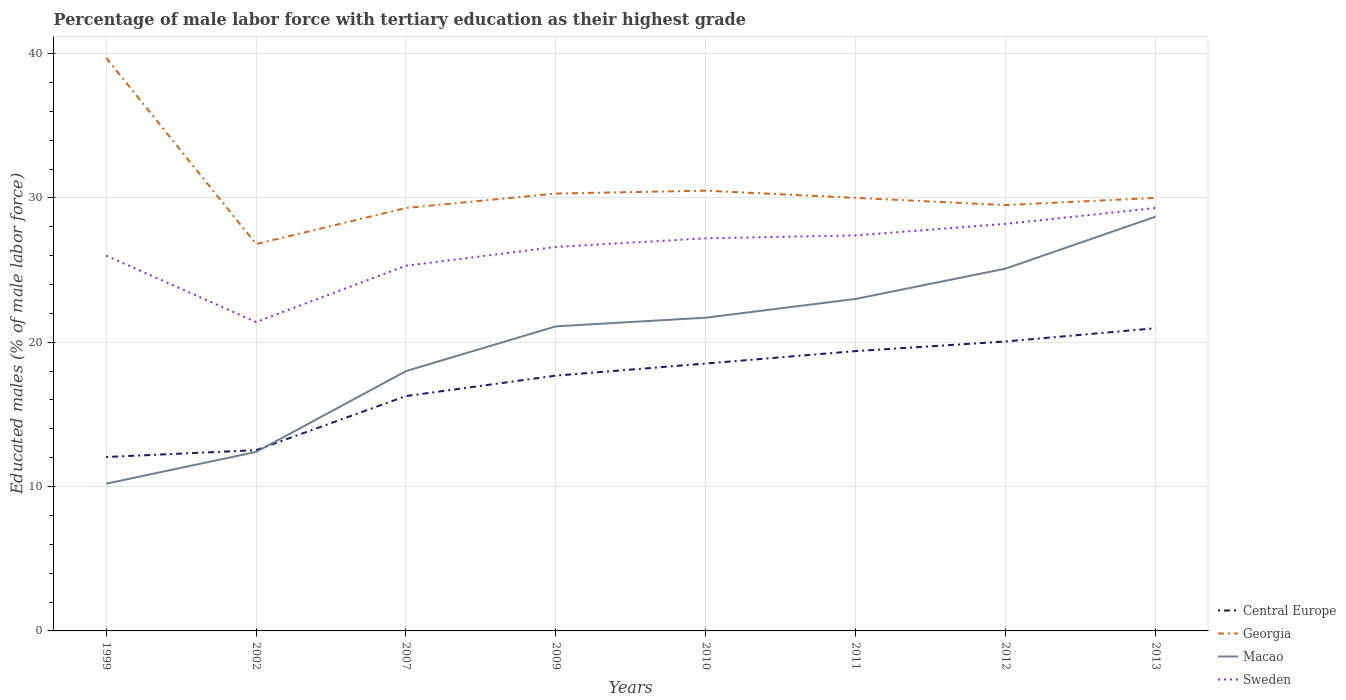Is the number of lines equal to the number of legend labels?
Keep it short and to the point. Yes. Across all years, what is the maximum percentage of male labor force with tertiary education in Macao?
Your answer should be very brief. 10.2. In which year was the percentage of male labor force with tertiary education in Macao maximum?
Give a very brief answer. 1999. What is the total percentage of male labor force with tertiary education in Central Europe in the graph?
Your answer should be compact. -0.47. What is the difference between the highest and the second highest percentage of male labor force with tertiary education in Sweden?
Make the answer very short. 7.9. What is the difference between the highest and the lowest percentage of male labor force with tertiary education in Macao?
Give a very brief answer. 5. How many lines are there?
Ensure brevity in your answer.  4. What is the difference between two consecutive major ticks on the Y-axis?
Provide a short and direct response. 10. Are the values on the major ticks of Y-axis written in scientific E-notation?
Your answer should be very brief. No. How are the legend labels stacked?
Your response must be concise. Vertical. What is the title of the graph?
Make the answer very short. Percentage of male labor force with tertiary education as their highest grade. Does "American Samoa" appear as one of the legend labels in the graph?
Provide a succinct answer. No. What is the label or title of the X-axis?
Make the answer very short. Years. What is the label or title of the Y-axis?
Your response must be concise. Educated males (% of male labor force). What is the Educated males (% of male labor force) in Central Europe in 1999?
Your answer should be very brief. 12.05. What is the Educated males (% of male labor force) of Georgia in 1999?
Ensure brevity in your answer.  39.7. What is the Educated males (% of male labor force) of Macao in 1999?
Make the answer very short. 10.2. What is the Educated males (% of male labor force) in Central Europe in 2002?
Provide a succinct answer. 12.52. What is the Educated males (% of male labor force) of Georgia in 2002?
Offer a very short reply. 26.8. What is the Educated males (% of male labor force) of Macao in 2002?
Provide a short and direct response. 12.4. What is the Educated males (% of male labor force) in Sweden in 2002?
Keep it short and to the point. 21.4. What is the Educated males (% of male labor force) of Central Europe in 2007?
Your answer should be very brief. 16.27. What is the Educated males (% of male labor force) of Georgia in 2007?
Keep it short and to the point. 29.3. What is the Educated males (% of male labor force) in Macao in 2007?
Your response must be concise. 18. What is the Educated males (% of male labor force) in Sweden in 2007?
Ensure brevity in your answer.  25.3. What is the Educated males (% of male labor force) in Central Europe in 2009?
Provide a succinct answer. 17.69. What is the Educated males (% of male labor force) of Georgia in 2009?
Provide a succinct answer. 30.3. What is the Educated males (% of male labor force) in Macao in 2009?
Offer a very short reply. 21.1. What is the Educated males (% of male labor force) in Sweden in 2009?
Keep it short and to the point. 26.6. What is the Educated males (% of male labor force) of Central Europe in 2010?
Offer a terse response. 18.52. What is the Educated males (% of male labor force) in Georgia in 2010?
Offer a terse response. 30.5. What is the Educated males (% of male labor force) in Macao in 2010?
Offer a very short reply. 21.7. What is the Educated males (% of male labor force) in Sweden in 2010?
Ensure brevity in your answer.  27.2. What is the Educated males (% of male labor force) of Central Europe in 2011?
Offer a very short reply. 19.39. What is the Educated males (% of male labor force) of Macao in 2011?
Your response must be concise. 23. What is the Educated males (% of male labor force) in Sweden in 2011?
Your answer should be compact. 27.4. What is the Educated males (% of male labor force) of Central Europe in 2012?
Offer a very short reply. 20.05. What is the Educated males (% of male labor force) of Georgia in 2012?
Offer a very short reply. 29.5. What is the Educated males (% of male labor force) in Macao in 2012?
Ensure brevity in your answer.  25.1. What is the Educated males (% of male labor force) of Sweden in 2012?
Ensure brevity in your answer.  28.2. What is the Educated males (% of male labor force) of Central Europe in 2013?
Keep it short and to the point. 20.97. What is the Educated males (% of male labor force) in Georgia in 2013?
Ensure brevity in your answer.  30. What is the Educated males (% of male labor force) of Macao in 2013?
Offer a very short reply. 28.7. What is the Educated males (% of male labor force) of Sweden in 2013?
Give a very brief answer. 29.3. Across all years, what is the maximum Educated males (% of male labor force) in Central Europe?
Keep it short and to the point. 20.97. Across all years, what is the maximum Educated males (% of male labor force) in Georgia?
Make the answer very short. 39.7. Across all years, what is the maximum Educated males (% of male labor force) of Macao?
Keep it short and to the point. 28.7. Across all years, what is the maximum Educated males (% of male labor force) in Sweden?
Offer a very short reply. 29.3. Across all years, what is the minimum Educated males (% of male labor force) of Central Europe?
Provide a short and direct response. 12.05. Across all years, what is the minimum Educated males (% of male labor force) in Georgia?
Provide a succinct answer. 26.8. Across all years, what is the minimum Educated males (% of male labor force) of Macao?
Give a very brief answer. 10.2. Across all years, what is the minimum Educated males (% of male labor force) in Sweden?
Your answer should be very brief. 21.4. What is the total Educated males (% of male labor force) of Central Europe in the graph?
Offer a terse response. 137.46. What is the total Educated males (% of male labor force) of Georgia in the graph?
Provide a short and direct response. 246.1. What is the total Educated males (% of male labor force) of Macao in the graph?
Your answer should be very brief. 160.2. What is the total Educated males (% of male labor force) in Sweden in the graph?
Make the answer very short. 211.4. What is the difference between the Educated males (% of male labor force) in Central Europe in 1999 and that in 2002?
Provide a short and direct response. -0.47. What is the difference between the Educated males (% of male labor force) of Georgia in 1999 and that in 2002?
Keep it short and to the point. 12.9. What is the difference between the Educated males (% of male labor force) of Sweden in 1999 and that in 2002?
Offer a terse response. 4.6. What is the difference between the Educated males (% of male labor force) of Central Europe in 1999 and that in 2007?
Your answer should be very brief. -4.22. What is the difference between the Educated males (% of male labor force) in Georgia in 1999 and that in 2007?
Your answer should be very brief. 10.4. What is the difference between the Educated males (% of male labor force) in Macao in 1999 and that in 2007?
Offer a very short reply. -7.8. What is the difference between the Educated males (% of male labor force) of Sweden in 1999 and that in 2007?
Your response must be concise. 0.7. What is the difference between the Educated males (% of male labor force) of Central Europe in 1999 and that in 2009?
Make the answer very short. -5.64. What is the difference between the Educated males (% of male labor force) of Macao in 1999 and that in 2009?
Provide a succinct answer. -10.9. What is the difference between the Educated males (% of male labor force) in Sweden in 1999 and that in 2009?
Provide a short and direct response. -0.6. What is the difference between the Educated males (% of male labor force) of Central Europe in 1999 and that in 2010?
Offer a terse response. -6.47. What is the difference between the Educated males (% of male labor force) in Georgia in 1999 and that in 2010?
Make the answer very short. 9.2. What is the difference between the Educated males (% of male labor force) of Macao in 1999 and that in 2010?
Ensure brevity in your answer.  -11.5. What is the difference between the Educated males (% of male labor force) in Sweden in 1999 and that in 2010?
Keep it short and to the point. -1.2. What is the difference between the Educated males (% of male labor force) in Central Europe in 1999 and that in 2011?
Make the answer very short. -7.34. What is the difference between the Educated males (% of male labor force) in Macao in 1999 and that in 2011?
Your response must be concise. -12.8. What is the difference between the Educated males (% of male labor force) in Sweden in 1999 and that in 2011?
Your answer should be compact. -1.4. What is the difference between the Educated males (% of male labor force) of Central Europe in 1999 and that in 2012?
Provide a short and direct response. -8. What is the difference between the Educated males (% of male labor force) in Macao in 1999 and that in 2012?
Your response must be concise. -14.9. What is the difference between the Educated males (% of male labor force) of Central Europe in 1999 and that in 2013?
Provide a succinct answer. -8.92. What is the difference between the Educated males (% of male labor force) of Georgia in 1999 and that in 2013?
Offer a very short reply. 9.7. What is the difference between the Educated males (% of male labor force) in Macao in 1999 and that in 2013?
Provide a short and direct response. -18.5. What is the difference between the Educated males (% of male labor force) of Sweden in 1999 and that in 2013?
Offer a very short reply. -3.3. What is the difference between the Educated males (% of male labor force) of Central Europe in 2002 and that in 2007?
Offer a very short reply. -3.75. What is the difference between the Educated males (% of male labor force) of Macao in 2002 and that in 2007?
Your answer should be compact. -5.6. What is the difference between the Educated males (% of male labor force) in Central Europe in 2002 and that in 2009?
Offer a terse response. -5.16. What is the difference between the Educated males (% of male labor force) in Macao in 2002 and that in 2009?
Your response must be concise. -8.7. What is the difference between the Educated males (% of male labor force) in Sweden in 2002 and that in 2009?
Provide a succinct answer. -5.2. What is the difference between the Educated males (% of male labor force) in Central Europe in 2002 and that in 2010?
Your answer should be very brief. -6. What is the difference between the Educated males (% of male labor force) of Macao in 2002 and that in 2010?
Give a very brief answer. -9.3. What is the difference between the Educated males (% of male labor force) of Sweden in 2002 and that in 2010?
Ensure brevity in your answer.  -5.8. What is the difference between the Educated males (% of male labor force) in Central Europe in 2002 and that in 2011?
Provide a succinct answer. -6.86. What is the difference between the Educated males (% of male labor force) in Macao in 2002 and that in 2011?
Your answer should be compact. -10.6. What is the difference between the Educated males (% of male labor force) in Central Europe in 2002 and that in 2012?
Ensure brevity in your answer.  -7.53. What is the difference between the Educated males (% of male labor force) in Macao in 2002 and that in 2012?
Your response must be concise. -12.7. What is the difference between the Educated males (% of male labor force) of Sweden in 2002 and that in 2012?
Provide a short and direct response. -6.8. What is the difference between the Educated males (% of male labor force) of Central Europe in 2002 and that in 2013?
Offer a very short reply. -8.45. What is the difference between the Educated males (% of male labor force) of Georgia in 2002 and that in 2013?
Offer a very short reply. -3.2. What is the difference between the Educated males (% of male labor force) of Macao in 2002 and that in 2013?
Your answer should be compact. -16.3. What is the difference between the Educated males (% of male labor force) in Sweden in 2002 and that in 2013?
Your answer should be compact. -7.9. What is the difference between the Educated males (% of male labor force) in Central Europe in 2007 and that in 2009?
Your answer should be compact. -1.42. What is the difference between the Educated males (% of male labor force) in Sweden in 2007 and that in 2009?
Your answer should be compact. -1.3. What is the difference between the Educated males (% of male labor force) in Central Europe in 2007 and that in 2010?
Provide a short and direct response. -2.25. What is the difference between the Educated males (% of male labor force) in Macao in 2007 and that in 2010?
Provide a short and direct response. -3.7. What is the difference between the Educated males (% of male labor force) of Sweden in 2007 and that in 2010?
Ensure brevity in your answer.  -1.9. What is the difference between the Educated males (% of male labor force) in Central Europe in 2007 and that in 2011?
Offer a terse response. -3.12. What is the difference between the Educated males (% of male labor force) in Georgia in 2007 and that in 2011?
Your response must be concise. -0.7. What is the difference between the Educated males (% of male labor force) of Central Europe in 2007 and that in 2012?
Keep it short and to the point. -3.78. What is the difference between the Educated males (% of male labor force) in Central Europe in 2007 and that in 2013?
Your response must be concise. -4.7. What is the difference between the Educated males (% of male labor force) in Georgia in 2007 and that in 2013?
Your answer should be compact. -0.7. What is the difference between the Educated males (% of male labor force) of Macao in 2007 and that in 2013?
Your response must be concise. -10.7. What is the difference between the Educated males (% of male labor force) of Sweden in 2007 and that in 2013?
Provide a short and direct response. -4. What is the difference between the Educated males (% of male labor force) of Central Europe in 2009 and that in 2010?
Provide a short and direct response. -0.84. What is the difference between the Educated males (% of male labor force) of Georgia in 2009 and that in 2010?
Make the answer very short. -0.2. What is the difference between the Educated males (% of male labor force) of Sweden in 2009 and that in 2010?
Offer a very short reply. -0.6. What is the difference between the Educated males (% of male labor force) of Central Europe in 2009 and that in 2011?
Keep it short and to the point. -1.7. What is the difference between the Educated males (% of male labor force) of Georgia in 2009 and that in 2011?
Make the answer very short. 0.3. What is the difference between the Educated males (% of male labor force) of Central Europe in 2009 and that in 2012?
Keep it short and to the point. -2.37. What is the difference between the Educated males (% of male labor force) in Georgia in 2009 and that in 2012?
Provide a succinct answer. 0.8. What is the difference between the Educated males (% of male labor force) of Macao in 2009 and that in 2012?
Your answer should be very brief. -4. What is the difference between the Educated males (% of male labor force) in Sweden in 2009 and that in 2012?
Your answer should be very brief. -1.6. What is the difference between the Educated males (% of male labor force) in Central Europe in 2009 and that in 2013?
Your answer should be compact. -3.28. What is the difference between the Educated males (% of male labor force) of Central Europe in 2010 and that in 2011?
Ensure brevity in your answer.  -0.86. What is the difference between the Educated males (% of male labor force) of Sweden in 2010 and that in 2011?
Your answer should be very brief. -0.2. What is the difference between the Educated males (% of male labor force) in Central Europe in 2010 and that in 2012?
Give a very brief answer. -1.53. What is the difference between the Educated males (% of male labor force) of Sweden in 2010 and that in 2012?
Your response must be concise. -1. What is the difference between the Educated males (% of male labor force) of Central Europe in 2010 and that in 2013?
Your answer should be compact. -2.45. What is the difference between the Educated males (% of male labor force) in Georgia in 2010 and that in 2013?
Offer a very short reply. 0.5. What is the difference between the Educated males (% of male labor force) of Macao in 2010 and that in 2013?
Ensure brevity in your answer.  -7. What is the difference between the Educated males (% of male labor force) of Sweden in 2010 and that in 2013?
Offer a very short reply. -2.1. What is the difference between the Educated males (% of male labor force) of Central Europe in 2011 and that in 2012?
Offer a very short reply. -0.66. What is the difference between the Educated males (% of male labor force) in Georgia in 2011 and that in 2012?
Give a very brief answer. 0.5. What is the difference between the Educated males (% of male labor force) of Central Europe in 2011 and that in 2013?
Offer a very short reply. -1.58. What is the difference between the Educated males (% of male labor force) of Macao in 2011 and that in 2013?
Your answer should be compact. -5.7. What is the difference between the Educated males (% of male labor force) of Central Europe in 2012 and that in 2013?
Keep it short and to the point. -0.92. What is the difference between the Educated males (% of male labor force) in Macao in 2012 and that in 2013?
Provide a succinct answer. -3.6. What is the difference between the Educated males (% of male labor force) in Central Europe in 1999 and the Educated males (% of male labor force) in Georgia in 2002?
Your response must be concise. -14.75. What is the difference between the Educated males (% of male labor force) of Central Europe in 1999 and the Educated males (% of male labor force) of Macao in 2002?
Give a very brief answer. -0.35. What is the difference between the Educated males (% of male labor force) of Central Europe in 1999 and the Educated males (% of male labor force) of Sweden in 2002?
Ensure brevity in your answer.  -9.35. What is the difference between the Educated males (% of male labor force) in Georgia in 1999 and the Educated males (% of male labor force) in Macao in 2002?
Your response must be concise. 27.3. What is the difference between the Educated males (% of male labor force) in Macao in 1999 and the Educated males (% of male labor force) in Sweden in 2002?
Keep it short and to the point. -11.2. What is the difference between the Educated males (% of male labor force) of Central Europe in 1999 and the Educated males (% of male labor force) of Georgia in 2007?
Give a very brief answer. -17.25. What is the difference between the Educated males (% of male labor force) in Central Europe in 1999 and the Educated males (% of male labor force) in Macao in 2007?
Provide a short and direct response. -5.95. What is the difference between the Educated males (% of male labor force) in Central Europe in 1999 and the Educated males (% of male labor force) in Sweden in 2007?
Your response must be concise. -13.25. What is the difference between the Educated males (% of male labor force) of Georgia in 1999 and the Educated males (% of male labor force) of Macao in 2007?
Your answer should be very brief. 21.7. What is the difference between the Educated males (% of male labor force) of Georgia in 1999 and the Educated males (% of male labor force) of Sweden in 2007?
Your answer should be very brief. 14.4. What is the difference between the Educated males (% of male labor force) in Macao in 1999 and the Educated males (% of male labor force) in Sweden in 2007?
Your answer should be very brief. -15.1. What is the difference between the Educated males (% of male labor force) in Central Europe in 1999 and the Educated males (% of male labor force) in Georgia in 2009?
Your response must be concise. -18.25. What is the difference between the Educated males (% of male labor force) of Central Europe in 1999 and the Educated males (% of male labor force) of Macao in 2009?
Give a very brief answer. -9.05. What is the difference between the Educated males (% of male labor force) in Central Europe in 1999 and the Educated males (% of male labor force) in Sweden in 2009?
Keep it short and to the point. -14.55. What is the difference between the Educated males (% of male labor force) of Georgia in 1999 and the Educated males (% of male labor force) of Macao in 2009?
Ensure brevity in your answer.  18.6. What is the difference between the Educated males (% of male labor force) in Macao in 1999 and the Educated males (% of male labor force) in Sweden in 2009?
Offer a terse response. -16.4. What is the difference between the Educated males (% of male labor force) in Central Europe in 1999 and the Educated males (% of male labor force) in Georgia in 2010?
Ensure brevity in your answer.  -18.45. What is the difference between the Educated males (% of male labor force) in Central Europe in 1999 and the Educated males (% of male labor force) in Macao in 2010?
Provide a short and direct response. -9.65. What is the difference between the Educated males (% of male labor force) of Central Europe in 1999 and the Educated males (% of male labor force) of Sweden in 2010?
Keep it short and to the point. -15.15. What is the difference between the Educated males (% of male labor force) in Georgia in 1999 and the Educated males (% of male labor force) in Macao in 2010?
Keep it short and to the point. 18. What is the difference between the Educated males (% of male labor force) of Macao in 1999 and the Educated males (% of male labor force) of Sweden in 2010?
Your answer should be compact. -17. What is the difference between the Educated males (% of male labor force) of Central Europe in 1999 and the Educated males (% of male labor force) of Georgia in 2011?
Keep it short and to the point. -17.95. What is the difference between the Educated males (% of male labor force) in Central Europe in 1999 and the Educated males (% of male labor force) in Macao in 2011?
Your answer should be very brief. -10.95. What is the difference between the Educated males (% of male labor force) of Central Europe in 1999 and the Educated males (% of male labor force) of Sweden in 2011?
Offer a terse response. -15.35. What is the difference between the Educated males (% of male labor force) of Georgia in 1999 and the Educated males (% of male labor force) of Sweden in 2011?
Provide a succinct answer. 12.3. What is the difference between the Educated males (% of male labor force) of Macao in 1999 and the Educated males (% of male labor force) of Sweden in 2011?
Offer a terse response. -17.2. What is the difference between the Educated males (% of male labor force) in Central Europe in 1999 and the Educated males (% of male labor force) in Georgia in 2012?
Your answer should be compact. -17.45. What is the difference between the Educated males (% of male labor force) of Central Europe in 1999 and the Educated males (% of male labor force) of Macao in 2012?
Provide a short and direct response. -13.05. What is the difference between the Educated males (% of male labor force) in Central Europe in 1999 and the Educated males (% of male labor force) in Sweden in 2012?
Keep it short and to the point. -16.15. What is the difference between the Educated males (% of male labor force) in Georgia in 1999 and the Educated males (% of male labor force) in Macao in 2012?
Provide a succinct answer. 14.6. What is the difference between the Educated males (% of male labor force) in Central Europe in 1999 and the Educated males (% of male labor force) in Georgia in 2013?
Make the answer very short. -17.95. What is the difference between the Educated males (% of male labor force) of Central Europe in 1999 and the Educated males (% of male labor force) of Macao in 2013?
Keep it short and to the point. -16.65. What is the difference between the Educated males (% of male labor force) in Central Europe in 1999 and the Educated males (% of male labor force) in Sweden in 2013?
Ensure brevity in your answer.  -17.25. What is the difference between the Educated males (% of male labor force) in Georgia in 1999 and the Educated males (% of male labor force) in Sweden in 2013?
Make the answer very short. 10.4. What is the difference between the Educated males (% of male labor force) of Macao in 1999 and the Educated males (% of male labor force) of Sweden in 2013?
Your response must be concise. -19.1. What is the difference between the Educated males (% of male labor force) of Central Europe in 2002 and the Educated males (% of male labor force) of Georgia in 2007?
Provide a short and direct response. -16.78. What is the difference between the Educated males (% of male labor force) of Central Europe in 2002 and the Educated males (% of male labor force) of Macao in 2007?
Make the answer very short. -5.48. What is the difference between the Educated males (% of male labor force) of Central Europe in 2002 and the Educated males (% of male labor force) of Sweden in 2007?
Make the answer very short. -12.78. What is the difference between the Educated males (% of male labor force) in Georgia in 2002 and the Educated males (% of male labor force) in Macao in 2007?
Make the answer very short. 8.8. What is the difference between the Educated males (% of male labor force) of Georgia in 2002 and the Educated males (% of male labor force) of Sweden in 2007?
Keep it short and to the point. 1.5. What is the difference between the Educated males (% of male labor force) of Macao in 2002 and the Educated males (% of male labor force) of Sweden in 2007?
Make the answer very short. -12.9. What is the difference between the Educated males (% of male labor force) in Central Europe in 2002 and the Educated males (% of male labor force) in Georgia in 2009?
Provide a short and direct response. -17.78. What is the difference between the Educated males (% of male labor force) of Central Europe in 2002 and the Educated males (% of male labor force) of Macao in 2009?
Your answer should be very brief. -8.58. What is the difference between the Educated males (% of male labor force) in Central Europe in 2002 and the Educated males (% of male labor force) in Sweden in 2009?
Offer a terse response. -14.08. What is the difference between the Educated males (% of male labor force) in Georgia in 2002 and the Educated males (% of male labor force) in Sweden in 2009?
Ensure brevity in your answer.  0.2. What is the difference between the Educated males (% of male labor force) in Macao in 2002 and the Educated males (% of male labor force) in Sweden in 2009?
Your response must be concise. -14.2. What is the difference between the Educated males (% of male labor force) of Central Europe in 2002 and the Educated males (% of male labor force) of Georgia in 2010?
Offer a very short reply. -17.98. What is the difference between the Educated males (% of male labor force) in Central Europe in 2002 and the Educated males (% of male labor force) in Macao in 2010?
Your answer should be compact. -9.18. What is the difference between the Educated males (% of male labor force) in Central Europe in 2002 and the Educated males (% of male labor force) in Sweden in 2010?
Your response must be concise. -14.68. What is the difference between the Educated males (% of male labor force) of Georgia in 2002 and the Educated males (% of male labor force) of Macao in 2010?
Make the answer very short. 5.1. What is the difference between the Educated males (% of male labor force) in Macao in 2002 and the Educated males (% of male labor force) in Sweden in 2010?
Offer a very short reply. -14.8. What is the difference between the Educated males (% of male labor force) of Central Europe in 2002 and the Educated males (% of male labor force) of Georgia in 2011?
Your response must be concise. -17.48. What is the difference between the Educated males (% of male labor force) of Central Europe in 2002 and the Educated males (% of male labor force) of Macao in 2011?
Your answer should be very brief. -10.48. What is the difference between the Educated males (% of male labor force) of Central Europe in 2002 and the Educated males (% of male labor force) of Sweden in 2011?
Make the answer very short. -14.88. What is the difference between the Educated males (% of male labor force) in Georgia in 2002 and the Educated males (% of male labor force) in Macao in 2011?
Offer a very short reply. 3.8. What is the difference between the Educated males (% of male labor force) of Georgia in 2002 and the Educated males (% of male labor force) of Sweden in 2011?
Give a very brief answer. -0.6. What is the difference between the Educated males (% of male labor force) in Macao in 2002 and the Educated males (% of male labor force) in Sweden in 2011?
Offer a very short reply. -15. What is the difference between the Educated males (% of male labor force) in Central Europe in 2002 and the Educated males (% of male labor force) in Georgia in 2012?
Offer a very short reply. -16.98. What is the difference between the Educated males (% of male labor force) of Central Europe in 2002 and the Educated males (% of male labor force) of Macao in 2012?
Keep it short and to the point. -12.58. What is the difference between the Educated males (% of male labor force) in Central Europe in 2002 and the Educated males (% of male labor force) in Sweden in 2012?
Offer a terse response. -15.68. What is the difference between the Educated males (% of male labor force) in Georgia in 2002 and the Educated males (% of male labor force) in Macao in 2012?
Keep it short and to the point. 1.7. What is the difference between the Educated males (% of male labor force) in Macao in 2002 and the Educated males (% of male labor force) in Sweden in 2012?
Offer a terse response. -15.8. What is the difference between the Educated males (% of male labor force) in Central Europe in 2002 and the Educated males (% of male labor force) in Georgia in 2013?
Your answer should be compact. -17.48. What is the difference between the Educated males (% of male labor force) of Central Europe in 2002 and the Educated males (% of male labor force) of Macao in 2013?
Your answer should be very brief. -16.18. What is the difference between the Educated males (% of male labor force) of Central Europe in 2002 and the Educated males (% of male labor force) of Sweden in 2013?
Make the answer very short. -16.78. What is the difference between the Educated males (% of male labor force) of Macao in 2002 and the Educated males (% of male labor force) of Sweden in 2013?
Your answer should be compact. -16.9. What is the difference between the Educated males (% of male labor force) of Central Europe in 2007 and the Educated males (% of male labor force) of Georgia in 2009?
Keep it short and to the point. -14.03. What is the difference between the Educated males (% of male labor force) in Central Europe in 2007 and the Educated males (% of male labor force) in Macao in 2009?
Make the answer very short. -4.83. What is the difference between the Educated males (% of male labor force) of Central Europe in 2007 and the Educated males (% of male labor force) of Sweden in 2009?
Make the answer very short. -10.33. What is the difference between the Educated males (% of male labor force) in Georgia in 2007 and the Educated males (% of male labor force) in Macao in 2009?
Keep it short and to the point. 8.2. What is the difference between the Educated males (% of male labor force) of Macao in 2007 and the Educated males (% of male labor force) of Sweden in 2009?
Your response must be concise. -8.6. What is the difference between the Educated males (% of male labor force) in Central Europe in 2007 and the Educated males (% of male labor force) in Georgia in 2010?
Provide a succinct answer. -14.23. What is the difference between the Educated males (% of male labor force) in Central Europe in 2007 and the Educated males (% of male labor force) in Macao in 2010?
Your answer should be compact. -5.43. What is the difference between the Educated males (% of male labor force) in Central Europe in 2007 and the Educated males (% of male labor force) in Sweden in 2010?
Provide a succinct answer. -10.93. What is the difference between the Educated males (% of male labor force) of Central Europe in 2007 and the Educated males (% of male labor force) of Georgia in 2011?
Offer a very short reply. -13.73. What is the difference between the Educated males (% of male labor force) in Central Europe in 2007 and the Educated males (% of male labor force) in Macao in 2011?
Your response must be concise. -6.73. What is the difference between the Educated males (% of male labor force) in Central Europe in 2007 and the Educated males (% of male labor force) in Sweden in 2011?
Your answer should be very brief. -11.13. What is the difference between the Educated males (% of male labor force) in Georgia in 2007 and the Educated males (% of male labor force) in Sweden in 2011?
Offer a very short reply. 1.9. What is the difference between the Educated males (% of male labor force) of Macao in 2007 and the Educated males (% of male labor force) of Sweden in 2011?
Keep it short and to the point. -9.4. What is the difference between the Educated males (% of male labor force) of Central Europe in 2007 and the Educated males (% of male labor force) of Georgia in 2012?
Provide a short and direct response. -13.23. What is the difference between the Educated males (% of male labor force) of Central Europe in 2007 and the Educated males (% of male labor force) of Macao in 2012?
Give a very brief answer. -8.83. What is the difference between the Educated males (% of male labor force) in Central Europe in 2007 and the Educated males (% of male labor force) in Sweden in 2012?
Your response must be concise. -11.93. What is the difference between the Educated males (% of male labor force) of Georgia in 2007 and the Educated males (% of male labor force) of Macao in 2012?
Provide a short and direct response. 4.2. What is the difference between the Educated males (% of male labor force) of Macao in 2007 and the Educated males (% of male labor force) of Sweden in 2012?
Offer a terse response. -10.2. What is the difference between the Educated males (% of male labor force) in Central Europe in 2007 and the Educated males (% of male labor force) in Georgia in 2013?
Ensure brevity in your answer.  -13.73. What is the difference between the Educated males (% of male labor force) of Central Europe in 2007 and the Educated males (% of male labor force) of Macao in 2013?
Ensure brevity in your answer.  -12.43. What is the difference between the Educated males (% of male labor force) of Central Europe in 2007 and the Educated males (% of male labor force) of Sweden in 2013?
Keep it short and to the point. -13.03. What is the difference between the Educated males (% of male labor force) in Georgia in 2007 and the Educated males (% of male labor force) in Sweden in 2013?
Offer a terse response. 0. What is the difference between the Educated males (% of male labor force) of Central Europe in 2009 and the Educated males (% of male labor force) of Georgia in 2010?
Keep it short and to the point. -12.81. What is the difference between the Educated males (% of male labor force) in Central Europe in 2009 and the Educated males (% of male labor force) in Macao in 2010?
Offer a very short reply. -4.01. What is the difference between the Educated males (% of male labor force) in Central Europe in 2009 and the Educated males (% of male labor force) in Sweden in 2010?
Give a very brief answer. -9.51. What is the difference between the Educated males (% of male labor force) in Georgia in 2009 and the Educated males (% of male labor force) in Macao in 2010?
Keep it short and to the point. 8.6. What is the difference between the Educated males (% of male labor force) of Central Europe in 2009 and the Educated males (% of male labor force) of Georgia in 2011?
Offer a terse response. -12.31. What is the difference between the Educated males (% of male labor force) in Central Europe in 2009 and the Educated males (% of male labor force) in Macao in 2011?
Your answer should be compact. -5.31. What is the difference between the Educated males (% of male labor force) in Central Europe in 2009 and the Educated males (% of male labor force) in Sweden in 2011?
Offer a very short reply. -9.71. What is the difference between the Educated males (% of male labor force) in Central Europe in 2009 and the Educated males (% of male labor force) in Georgia in 2012?
Offer a very short reply. -11.81. What is the difference between the Educated males (% of male labor force) of Central Europe in 2009 and the Educated males (% of male labor force) of Macao in 2012?
Provide a succinct answer. -7.41. What is the difference between the Educated males (% of male labor force) of Central Europe in 2009 and the Educated males (% of male labor force) of Sweden in 2012?
Your answer should be very brief. -10.51. What is the difference between the Educated males (% of male labor force) in Georgia in 2009 and the Educated males (% of male labor force) in Sweden in 2012?
Make the answer very short. 2.1. What is the difference between the Educated males (% of male labor force) in Macao in 2009 and the Educated males (% of male labor force) in Sweden in 2012?
Keep it short and to the point. -7.1. What is the difference between the Educated males (% of male labor force) in Central Europe in 2009 and the Educated males (% of male labor force) in Georgia in 2013?
Ensure brevity in your answer.  -12.31. What is the difference between the Educated males (% of male labor force) of Central Europe in 2009 and the Educated males (% of male labor force) of Macao in 2013?
Ensure brevity in your answer.  -11.01. What is the difference between the Educated males (% of male labor force) of Central Europe in 2009 and the Educated males (% of male labor force) of Sweden in 2013?
Keep it short and to the point. -11.61. What is the difference between the Educated males (% of male labor force) of Georgia in 2009 and the Educated males (% of male labor force) of Sweden in 2013?
Give a very brief answer. 1. What is the difference between the Educated males (% of male labor force) in Macao in 2009 and the Educated males (% of male labor force) in Sweden in 2013?
Your answer should be compact. -8.2. What is the difference between the Educated males (% of male labor force) of Central Europe in 2010 and the Educated males (% of male labor force) of Georgia in 2011?
Offer a terse response. -11.48. What is the difference between the Educated males (% of male labor force) in Central Europe in 2010 and the Educated males (% of male labor force) in Macao in 2011?
Offer a very short reply. -4.48. What is the difference between the Educated males (% of male labor force) in Central Europe in 2010 and the Educated males (% of male labor force) in Sweden in 2011?
Your response must be concise. -8.88. What is the difference between the Educated males (% of male labor force) of Georgia in 2010 and the Educated males (% of male labor force) of Sweden in 2011?
Your answer should be very brief. 3.1. What is the difference between the Educated males (% of male labor force) of Macao in 2010 and the Educated males (% of male labor force) of Sweden in 2011?
Give a very brief answer. -5.7. What is the difference between the Educated males (% of male labor force) in Central Europe in 2010 and the Educated males (% of male labor force) in Georgia in 2012?
Provide a short and direct response. -10.98. What is the difference between the Educated males (% of male labor force) in Central Europe in 2010 and the Educated males (% of male labor force) in Macao in 2012?
Your answer should be compact. -6.58. What is the difference between the Educated males (% of male labor force) of Central Europe in 2010 and the Educated males (% of male labor force) of Sweden in 2012?
Your answer should be compact. -9.68. What is the difference between the Educated males (% of male labor force) of Georgia in 2010 and the Educated males (% of male labor force) of Macao in 2012?
Keep it short and to the point. 5.4. What is the difference between the Educated males (% of male labor force) of Central Europe in 2010 and the Educated males (% of male labor force) of Georgia in 2013?
Offer a terse response. -11.48. What is the difference between the Educated males (% of male labor force) of Central Europe in 2010 and the Educated males (% of male labor force) of Macao in 2013?
Provide a succinct answer. -10.18. What is the difference between the Educated males (% of male labor force) of Central Europe in 2010 and the Educated males (% of male labor force) of Sweden in 2013?
Make the answer very short. -10.78. What is the difference between the Educated males (% of male labor force) of Central Europe in 2011 and the Educated males (% of male labor force) of Georgia in 2012?
Make the answer very short. -10.11. What is the difference between the Educated males (% of male labor force) of Central Europe in 2011 and the Educated males (% of male labor force) of Macao in 2012?
Keep it short and to the point. -5.71. What is the difference between the Educated males (% of male labor force) of Central Europe in 2011 and the Educated males (% of male labor force) of Sweden in 2012?
Provide a succinct answer. -8.81. What is the difference between the Educated males (% of male labor force) in Georgia in 2011 and the Educated males (% of male labor force) in Macao in 2012?
Your answer should be very brief. 4.9. What is the difference between the Educated males (% of male labor force) in Macao in 2011 and the Educated males (% of male labor force) in Sweden in 2012?
Your answer should be compact. -5.2. What is the difference between the Educated males (% of male labor force) of Central Europe in 2011 and the Educated males (% of male labor force) of Georgia in 2013?
Provide a short and direct response. -10.61. What is the difference between the Educated males (% of male labor force) in Central Europe in 2011 and the Educated males (% of male labor force) in Macao in 2013?
Your answer should be compact. -9.31. What is the difference between the Educated males (% of male labor force) in Central Europe in 2011 and the Educated males (% of male labor force) in Sweden in 2013?
Offer a terse response. -9.91. What is the difference between the Educated males (% of male labor force) in Central Europe in 2012 and the Educated males (% of male labor force) in Georgia in 2013?
Offer a very short reply. -9.95. What is the difference between the Educated males (% of male labor force) in Central Europe in 2012 and the Educated males (% of male labor force) in Macao in 2013?
Your answer should be compact. -8.65. What is the difference between the Educated males (% of male labor force) in Central Europe in 2012 and the Educated males (% of male labor force) in Sweden in 2013?
Make the answer very short. -9.25. What is the average Educated males (% of male labor force) in Central Europe per year?
Provide a short and direct response. 17.18. What is the average Educated males (% of male labor force) of Georgia per year?
Your answer should be compact. 30.76. What is the average Educated males (% of male labor force) in Macao per year?
Give a very brief answer. 20.02. What is the average Educated males (% of male labor force) of Sweden per year?
Keep it short and to the point. 26.43. In the year 1999, what is the difference between the Educated males (% of male labor force) of Central Europe and Educated males (% of male labor force) of Georgia?
Give a very brief answer. -27.65. In the year 1999, what is the difference between the Educated males (% of male labor force) in Central Europe and Educated males (% of male labor force) in Macao?
Your response must be concise. 1.85. In the year 1999, what is the difference between the Educated males (% of male labor force) in Central Europe and Educated males (% of male labor force) in Sweden?
Provide a short and direct response. -13.95. In the year 1999, what is the difference between the Educated males (% of male labor force) of Georgia and Educated males (% of male labor force) of Macao?
Ensure brevity in your answer.  29.5. In the year 1999, what is the difference between the Educated males (% of male labor force) in Georgia and Educated males (% of male labor force) in Sweden?
Provide a short and direct response. 13.7. In the year 1999, what is the difference between the Educated males (% of male labor force) in Macao and Educated males (% of male labor force) in Sweden?
Provide a short and direct response. -15.8. In the year 2002, what is the difference between the Educated males (% of male labor force) of Central Europe and Educated males (% of male labor force) of Georgia?
Offer a terse response. -14.28. In the year 2002, what is the difference between the Educated males (% of male labor force) in Central Europe and Educated males (% of male labor force) in Macao?
Your response must be concise. 0.12. In the year 2002, what is the difference between the Educated males (% of male labor force) of Central Europe and Educated males (% of male labor force) of Sweden?
Provide a succinct answer. -8.88. In the year 2007, what is the difference between the Educated males (% of male labor force) in Central Europe and Educated males (% of male labor force) in Georgia?
Ensure brevity in your answer.  -13.03. In the year 2007, what is the difference between the Educated males (% of male labor force) of Central Europe and Educated males (% of male labor force) of Macao?
Make the answer very short. -1.73. In the year 2007, what is the difference between the Educated males (% of male labor force) in Central Europe and Educated males (% of male labor force) in Sweden?
Your answer should be very brief. -9.03. In the year 2009, what is the difference between the Educated males (% of male labor force) of Central Europe and Educated males (% of male labor force) of Georgia?
Offer a terse response. -12.61. In the year 2009, what is the difference between the Educated males (% of male labor force) of Central Europe and Educated males (% of male labor force) of Macao?
Offer a very short reply. -3.41. In the year 2009, what is the difference between the Educated males (% of male labor force) of Central Europe and Educated males (% of male labor force) of Sweden?
Your answer should be compact. -8.91. In the year 2009, what is the difference between the Educated males (% of male labor force) in Macao and Educated males (% of male labor force) in Sweden?
Your response must be concise. -5.5. In the year 2010, what is the difference between the Educated males (% of male labor force) in Central Europe and Educated males (% of male labor force) in Georgia?
Your answer should be compact. -11.98. In the year 2010, what is the difference between the Educated males (% of male labor force) of Central Europe and Educated males (% of male labor force) of Macao?
Provide a short and direct response. -3.18. In the year 2010, what is the difference between the Educated males (% of male labor force) in Central Europe and Educated males (% of male labor force) in Sweden?
Ensure brevity in your answer.  -8.68. In the year 2010, what is the difference between the Educated males (% of male labor force) in Georgia and Educated males (% of male labor force) in Sweden?
Your answer should be very brief. 3.3. In the year 2010, what is the difference between the Educated males (% of male labor force) in Macao and Educated males (% of male labor force) in Sweden?
Provide a short and direct response. -5.5. In the year 2011, what is the difference between the Educated males (% of male labor force) of Central Europe and Educated males (% of male labor force) of Georgia?
Keep it short and to the point. -10.61. In the year 2011, what is the difference between the Educated males (% of male labor force) of Central Europe and Educated males (% of male labor force) of Macao?
Offer a terse response. -3.61. In the year 2011, what is the difference between the Educated males (% of male labor force) of Central Europe and Educated males (% of male labor force) of Sweden?
Your response must be concise. -8.01. In the year 2011, what is the difference between the Educated males (% of male labor force) in Georgia and Educated males (% of male labor force) in Macao?
Offer a very short reply. 7. In the year 2011, what is the difference between the Educated males (% of male labor force) of Macao and Educated males (% of male labor force) of Sweden?
Keep it short and to the point. -4.4. In the year 2012, what is the difference between the Educated males (% of male labor force) in Central Europe and Educated males (% of male labor force) in Georgia?
Give a very brief answer. -9.45. In the year 2012, what is the difference between the Educated males (% of male labor force) of Central Europe and Educated males (% of male labor force) of Macao?
Your response must be concise. -5.05. In the year 2012, what is the difference between the Educated males (% of male labor force) of Central Europe and Educated males (% of male labor force) of Sweden?
Offer a very short reply. -8.15. In the year 2012, what is the difference between the Educated males (% of male labor force) in Georgia and Educated males (% of male labor force) in Sweden?
Your answer should be compact. 1.3. In the year 2013, what is the difference between the Educated males (% of male labor force) in Central Europe and Educated males (% of male labor force) in Georgia?
Make the answer very short. -9.03. In the year 2013, what is the difference between the Educated males (% of male labor force) of Central Europe and Educated males (% of male labor force) of Macao?
Offer a terse response. -7.73. In the year 2013, what is the difference between the Educated males (% of male labor force) in Central Europe and Educated males (% of male labor force) in Sweden?
Your answer should be very brief. -8.33. In the year 2013, what is the difference between the Educated males (% of male labor force) of Georgia and Educated males (% of male labor force) of Macao?
Provide a succinct answer. 1.3. In the year 2013, what is the difference between the Educated males (% of male labor force) in Macao and Educated males (% of male labor force) in Sweden?
Offer a terse response. -0.6. What is the ratio of the Educated males (% of male labor force) in Central Europe in 1999 to that in 2002?
Make the answer very short. 0.96. What is the ratio of the Educated males (% of male labor force) in Georgia in 1999 to that in 2002?
Provide a succinct answer. 1.48. What is the ratio of the Educated males (% of male labor force) in Macao in 1999 to that in 2002?
Keep it short and to the point. 0.82. What is the ratio of the Educated males (% of male labor force) of Sweden in 1999 to that in 2002?
Give a very brief answer. 1.22. What is the ratio of the Educated males (% of male labor force) of Central Europe in 1999 to that in 2007?
Your answer should be compact. 0.74. What is the ratio of the Educated males (% of male labor force) in Georgia in 1999 to that in 2007?
Offer a very short reply. 1.35. What is the ratio of the Educated males (% of male labor force) of Macao in 1999 to that in 2007?
Ensure brevity in your answer.  0.57. What is the ratio of the Educated males (% of male labor force) in Sweden in 1999 to that in 2007?
Your answer should be very brief. 1.03. What is the ratio of the Educated males (% of male labor force) in Central Europe in 1999 to that in 2009?
Keep it short and to the point. 0.68. What is the ratio of the Educated males (% of male labor force) in Georgia in 1999 to that in 2009?
Offer a very short reply. 1.31. What is the ratio of the Educated males (% of male labor force) in Macao in 1999 to that in 2009?
Your answer should be very brief. 0.48. What is the ratio of the Educated males (% of male labor force) of Sweden in 1999 to that in 2009?
Make the answer very short. 0.98. What is the ratio of the Educated males (% of male labor force) in Central Europe in 1999 to that in 2010?
Your answer should be very brief. 0.65. What is the ratio of the Educated males (% of male labor force) of Georgia in 1999 to that in 2010?
Provide a short and direct response. 1.3. What is the ratio of the Educated males (% of male labor force) in Macao in 1999 to that in 2010?
Your answer should be very brief. 0.47. What is the ratio of the Educated males (% of male labor force) in Sweden in 1999 to that in 2010?
Your answer should be compact. 0.96. What is the ratio of the Educated males (% of male labor force) in Central Europe in 1999 to that in 2011?
Offer a very short reply. 0.62. What is the ratio of the Educated males (% of male labor force) in Georgia in 1999 to that in 2011?
Keep it short and to the point. 1.32. What is the ratio of the Educated males (% of male labor force) in Macao in 1999 to that in 2011?
Keep it short and to the point. 0.44. What is the ratio of the Educated males (% of male labor force) in Sweden in 1999 to that in 2011?
Give a very brief answer. 0.95. What is the ratio of the Educated males (% of male labor force) of Central Europe in 1999 to that in 2012?
Your answer should be very brief. 0.6. What is the ratio of the Educated males (% of male labor force) in Georgia in 1999 to that in 2012?
Your response must be concise. 1.35. What is the ratio of the Educated males (% of male labor force) in Macao in 1999 to that in 2012?
Ensure brevity in your answer.  0.41. What is the ratio of the Educated males (% of male labor force) of Sweden in 1999 to that in 2012?
Your answer should be compact. 0.92. What is the ratio of the Educated males (% of male labor force) in Central Europe in 1999 to that in 2013?
Your answer should be compact. 0.57. What is the ratio of the Educated males (% of male labor force) in Georgia in 1999 to that in 2013?
Offer a terse response. 1.32. What is the ratio of the Educated males (% of male labor force) in Macao in 1999 to that in 2013?
Keep it short and to the point. 0.36. What is the ratio of the Educated males (% of male labor force) of Sweden in 1999 to that in 2013?
Give a very brief answer. 0.89. What is the ratio of the Educated males (% of male labor force) of Central Europe in 2002 to that in 2007?
Keep it short and to the point. 0.77. What is the ratio of the Educated males (% of male labor force) in Georgia in 2002 to that in 2007?
Give a very brief answer. 0.91. What is the ratio of the Educated males (% of male labor force) in Macao in 2002 to that in 2007?
Ensure brevity in your answer.  0.69. What is the ratio of the Educated males (% of male labor force) in Sweden in 2002 to that in 2007?
Your answer should be very brief. 0.85. What is the ratio of the Educated males (% of male labor force) in Central Europe in 2002 to that in 2009?
Give a very brief answer. 0.71. What is the ratio of the Educated males (% of male labor force) of Georgia in 2002 to that in 2009?
Offer a terse response. 0.88. What is the ratio of the Educated males (% of male labor force) in Macao in 2002 to that in 2009?
Keep it short and to the point. 0.59. What is the ratio of the Educated males (% of male labor force) of Sweden in 2002 to that in 2009?
Make the answer very short. 0.8. What is the ratio of the Educated males (% of male labor force) of Central Europe in 2002 to that in 2010?
Your answer should be compact. 0.68. What is the ratio of the Educated males (% of male labor force) in Georgia in 2002 to that in 2010?
Give a very brief answer. 0.88. What is the ratio of the Educated males (% of male labor force) of Sweden in 2002 to that in 2010?
Offer a terse response. 0.79. What is the ratio of the Educated males (% of male labor force) in Central Europe in 2002 to that in 2011?
Give a very brief answer. 0.65. What is the ratio of the Educated males (% of male labor force) of Georgia in 2002 to that in 2011?
Your answer should be very brief. 0.89. What is the ratio of the Educated males (% of male labor force) in Macao in 2002 to that in 2011?
Offer a terse response. 0.54. What is the ratio of the Educated males (% of male labor force) of Sweden in 2002 to that in 2011?
Give a very brief answer. 0.78. What is the ratio of the Educated males (% of male labor force) of Central Europe in 2002 to that in 2012?
Provide a succinct answer. 0.62. What is the ratio of the Educated males (% of male labor force) of Georgia in 2002 to that in 2012?
Offer a very short reply. 0.91. What is the ratio of the Educated males (% of male labor force) of Macao in 2002 to that in 2012?
Offer a very short reply. 0.49. What is the ratio of the Educated males (% of male labor force) in Sweden in 2002 to that in 2012?
Your answer should be very brief. 0.76. What is the ratio of the Educated males (% of male labor force) in Central Europe in 2002 to that in 2013?
Your answer should be very brief. 0.6. What is the ratio of the Educated males (% of male labor force) in Georgia in 2002 to that in 2013?
Offer a terse response. 0.89. What is the ratio of the Educated males (% of male labor force) in Macao in 2002 to that in 2013?
Provide a succinct answer. 0.43. What is the ratio of the Educated males (% of male labor force) of Sweden in 2002 to that in 2013?
Keep it short and to the point. 0.73. What is the ratio of the Educated males (% of male labor force) of Macao in 2007 to that in 2009?
Provide a succinct answer. 0.85. What is the ratio of the Educated males (% of male labor force) of Sweden in 2007 to that in 2009?
Provide a succinct answer. 0.95. What is the ratio of the Educated males (% of male labor force) of Central Europe in 2007 to that in 2010?
Give a very brief answer. 0.88. What is the ratio of the Educated males (% of male labor force) in Georgia in 2007 to that in 2010?
Provide a succinct answer. 0.96. What is the ratio of the Educated males (% of male labor force) in Macao in 2007 to that in 2010?
Ensure brevity in your answer.  0.83. What is the ratio of the Educated males (% of male labor force) in Sweden in 2007 to that in 2010?
Provide a succinct answer. 0.93. What is the ratio of the Educated males (% of male labor force) in Central Europe in 2007 to that in 2011?
Ensure brevity in your answer.  0.84. What is the ratio of the Educated males (% of male labor force) of Georgia in 2007 to that in 2011?
Offer a terse response. 0.98. What is the ratio of the Educated males (% of male labor force) of Macao in 2007 to that in 2011?
Offer a terse response. 0.78. What is the ratio of the Educated males (% of male labor force) in Sweden in 2007 to that in 2011?
Your answer should be compact. 0.92. What is the ratio of the Educated males (% of male labor force) of Central Europe in 2007 to that in 2012?
Keep it short and to the point. 0.81. What is the ratio of the Educated males (% of male labor force) of Georgia in 2007 to that in 2012?
Provide a succinct answer. 0.99. What is the ratio of the Educated males (% of male labor force) in Macao in 2007 to that in 2012?
Make the answer very short. 0.72. What is the ratio of the Educated males (% of male labor force) of Sweden in 2007 to that in 2012?
Your response must be concise. 0.9. What is the ratio of the Educated males (% of male labor force) in Central Europe in 2007 to that in 2013?
Provide a succinct answer. 0.78. What is the ratio of the Educated males (% of male labor force) in Georgia in 2007 to that in 2013?
Your answer should be very brief. 0.98. What is the ratio of the Educated males (% of male labor force) in Macao in 2007 to that in 2013?
Provide a short and direct response. 0.63. What is the ratio of the Educated males (% of male labor force) in Sweden in 2007 to that in 2013?
Provide a short and direct response. 0.86. What is the ratio of the Educated males (% of male labor force) in Central Europe in 2009 to that in 2010?
Your answer should be compact. 0.95. What is the ratio of the Educated males (% of male labor force) in Georgia in 2009 to that in 2010?
Make the answer very short. 0.99. What is the ratio of the Educated males (% of male labor force) of Macao in 2009 to that in 2010?
Your response must be concise. 0.97. What is the ratio of the Educated males (% of male labor force) of Sweden in 2009 to that in 2010?
Give a very brief answer. 0.98. What is the ratio of the Educated males (% of male labor force) of Central Europe in 2009 to that in 2011?
Your response must be concise. 0.91. What is the ratio of the Educated males (% of male labor force) in Georgia in 2009 to that in 2011?
Provide a succinct answer. 1.01. What is the ratio of the Educated males (% of male labor force) of Macao in 2009 to that in 2011?
Your response must be concise. 0.92. What is the ratio of the Educated males (% of male labor force) in Sweden in 2009 to that in 2011?
Offer a terse response. 0.97. What is the ratio of the Educated males (% of male labor force) of Central Europe in 2009 to that in 2012?
Offer a terse response. 0.88. What is the ratio of the Educated males (% of male labor force) of Georgia in 2009 to that in 2012?
Your answer should be very brief. 1.03. What is the ratio of the Educated males (% of male labor force) in Macao in 2009 to that in 2012?
Give a very brief answer. 0.84. What is the ratio of the Educated males (% of male labor force) of Sweden in 2009 to that in 2012?
Give a very brief answer. 0.94. What is the ratio of the Educated males (% of male labor force) in Central Europe in 2009 to that in 2013?
Your response must be concise. 0.84. What is the ratio of the Educated males (% of male labor force) of Georgia in 2009 to that in 2013?
Give a very brief answer. 1.01. What is the ratio of the Educated males (% of male labor force) of Macao in 2009 to that in 2013?
Provide a short and direct response. 0.74. What is the ratio of the Educated males (% of male labor force) of Sweden in 2009 to that in 2013?
Give a very brief answer. 0.91. What is the ratio of the Educated males (% of male labor force) of Central Europe in 2010 to that in 2011?
Your response must be concise. 0.96. What is the ratio of the Educated males (% of male labor force) of Georgia in 2010 to that in 2011?
Your answer should be compact. 1.02. What is the ratio of the Educated males (% of male labor force) in Macao in 2010 to that in 2011?
Ensure brevity in your answer.  0.94. What is the ratio of the Educated males (% of male labor force) in Central Europe in 2010 to that in 2012?
Provide a succinct answer. 0.92. What is the ratio of the Educated males (% of male labor force) in Georgia in 2010 to that in 2012?
Provide a succinct answer. 1.03. What is the ratio of the Educated males (% of male labor force) of Macao in 2010 to that in 2012?
Your answer should be very brief. 0.86. What is the ratio of the Educated males (% of male labor force) in Sweden in 2010 to that in 2012?
Keep it short and to the point. 0.96. What is the ratio of the Educated males (% of male labor force) in Central Europe in 2010 to that in 2013?
Offer a terse response. 0.88. What is the ratio of the Educated males (% of male labor force) in Georgia in 2010 to that in 2013?
Provide a short and direct response. 1.02. What is the ratio of the Educated males (% of male labor force) in Macao in 2010 to that in 2013?
Offer a terse response. 0.76. What is the ratio of the Educated males (% of male labor force) in Sweden in 2010 to that in 2013?
Keep it short and to the point. 0.93. What is the ratio of the Educated males (% of male labor force) of Central Europe in 2011 to that in 2012?
Your response must be concise. 0.97. What is the ratio of the Educated males (% of male labor force) in Georgia in 2011 to that in 2012?
Your response must be concise. 1.02. What is the ratio of the Educated males (% of male labor force) of Macao in 2011 to that in 2012?
Offer a very short reply. 0.92. What is the ratio of the Educated males (% of male labor force) in Sweden in 2011 to that in 2012?
Your response must be concise. 0.97. What is the ratio of the Educated males (% of male labor force) in Central Europe in 2011 to that in 2013?
Your response must be concise. 0.92. What is the ratio of the Educated males (% of male labor force) of Macao in 2011 to that in 2013?
Provide a short and direct response. 0.8. What is the ratio of the Educated males (% of male labor force) in Sweden in 2011 to that in 2013?
Provide a succinct answer. 0.94. What is the ratio of the Educated males (% of male labor force) in Central Europe in 2012 to that in 2013?
Provide a succinct answer. 0.96. What is the ratio of the Educated males (% of male labor force) in Georgia in 2012 to that in 2013?
Offer a terse response. 0.98. What is the ratio of the Educated males (% of male labor force) in Macao in 2012 to that in 2013?
Provide a short and direct response. 0.87. What is the ratio of the Educated males (% of male labor force) in Sweden in 2012 to that in 2013?
Your response must be concise. 0.96. What is the difference between the highest and the second highest Educated males (% of male labor force) in Central Europe?
Make the answer very short. 0.92. What is the difference between the highest and the second highest Educated males (% of male labor force) in Georgia?
Your answer should be compact. 9.2. What is the difference between the highest and the second highest Educated males (% of male labor force) of Macao?
Offer a very short reply. 3.6. What is the difference between the highest and the second highest Educated males (% of male labor force) of Sweden?
Offer a terse response. 1.1. What is the difference between the highest and the lowest Educated males (% of male labor force) of Central Europe?
Provide a short and direct response. 8.92. What is the difference between the highest and the lowest Educated males (% of male labor force) in Macao?
Your response must be concise. 18.5. 